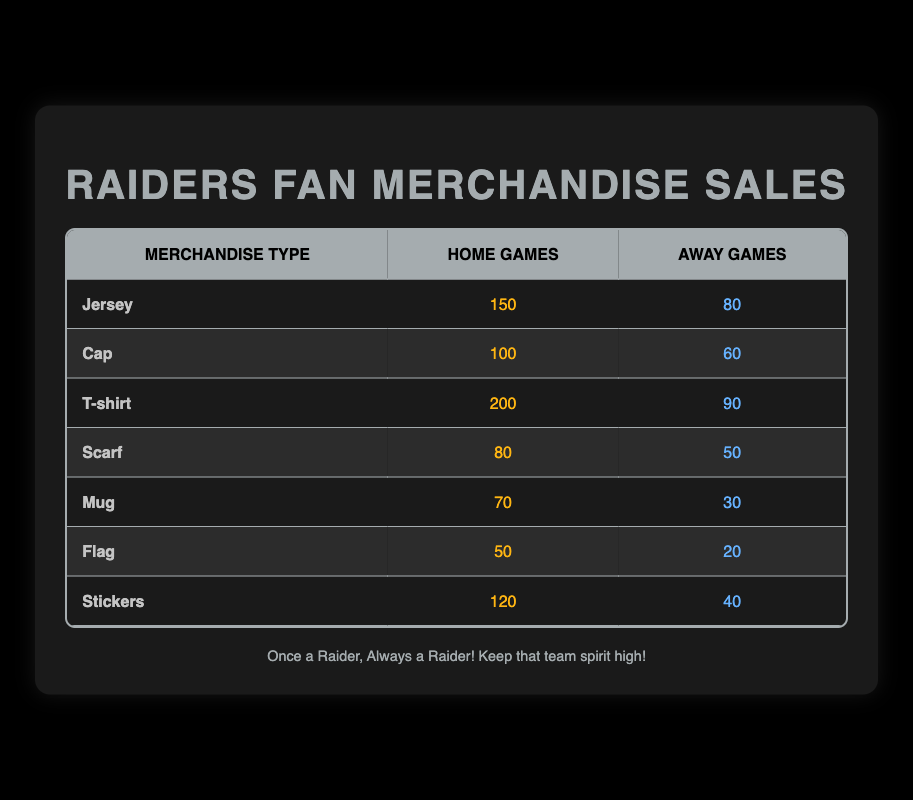What was the total number of jerseys sold during both home and away games? To find the total number of jerseys sold, add the sales from home games (150) to the sales from away games (80). This gives you 150 + 80 = 230.
Answer: 230 Which merchandise type had the highest sales during home games? By reviewing the home game column, the highest sales are for the T-shirt, which sold 200 units compared to the other merchandise types.
Answer: T-shirt Did more caps sell during home games than flags? For caps, 100 were sold during home games, while for flags, only 50 were sold. Since 100 is greater than 50, more caps sold during home games than flags.
Answer: Yes What is the average number of mugs sold during both home and away games? First, sum the sales of mugs in home games (70) and away games (30), giving us 70 + 30 = 100. Then, since there is one type of merchandise (mug), the average is 100/1 = 100.
Answer: 100 What is the difference in sales for T-shirts between home games and away games? The sales of T-shirts during home games is 200, while for away games, it is 90. The difference is calculated by subtracting away sales from home sales: 200 - 90 = 110.
Answer: 110 Which merchandise type had the lowest overall sales (home and away combined)? To determine the lowest overall sales, sum up the sales for each type of merchandise. After calculating, the least sold item can be identified. Flags had the lowest overall sales: 50 (home) + 20 (away) = 70.
Answer: Flag Were more stickers sold during home games or T-shirts during away games? Stickers sold 120 during home games, while T-shirts sold 90 during away games. Since 120 is greater than 90, more stickers were sold during home games than T-shirts during away games.
Answer: Yes 